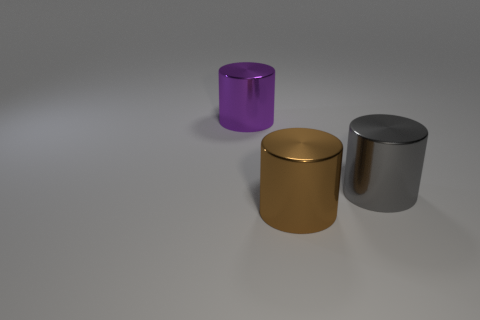Subtract all brown cylinders. How many cylinders are left? 2 Add 2 brown cylinders. How many objects exist? 5 Subtract all brown cylinders. How many cylinders are left? 2 Subtract all blue cylinders. Subtract all green spheres. How many cylinders are left? 3 Subtract all big balls. Subtract all large things. How many objects are left? 0 Add 3 brown metallic cylinders. How many brown metallic cylinders are left? 4 Add 2 brown metal spheres. How many brown metal spheres exist? 2 Subtract 0 gray cubes. How many objects are left? 3 